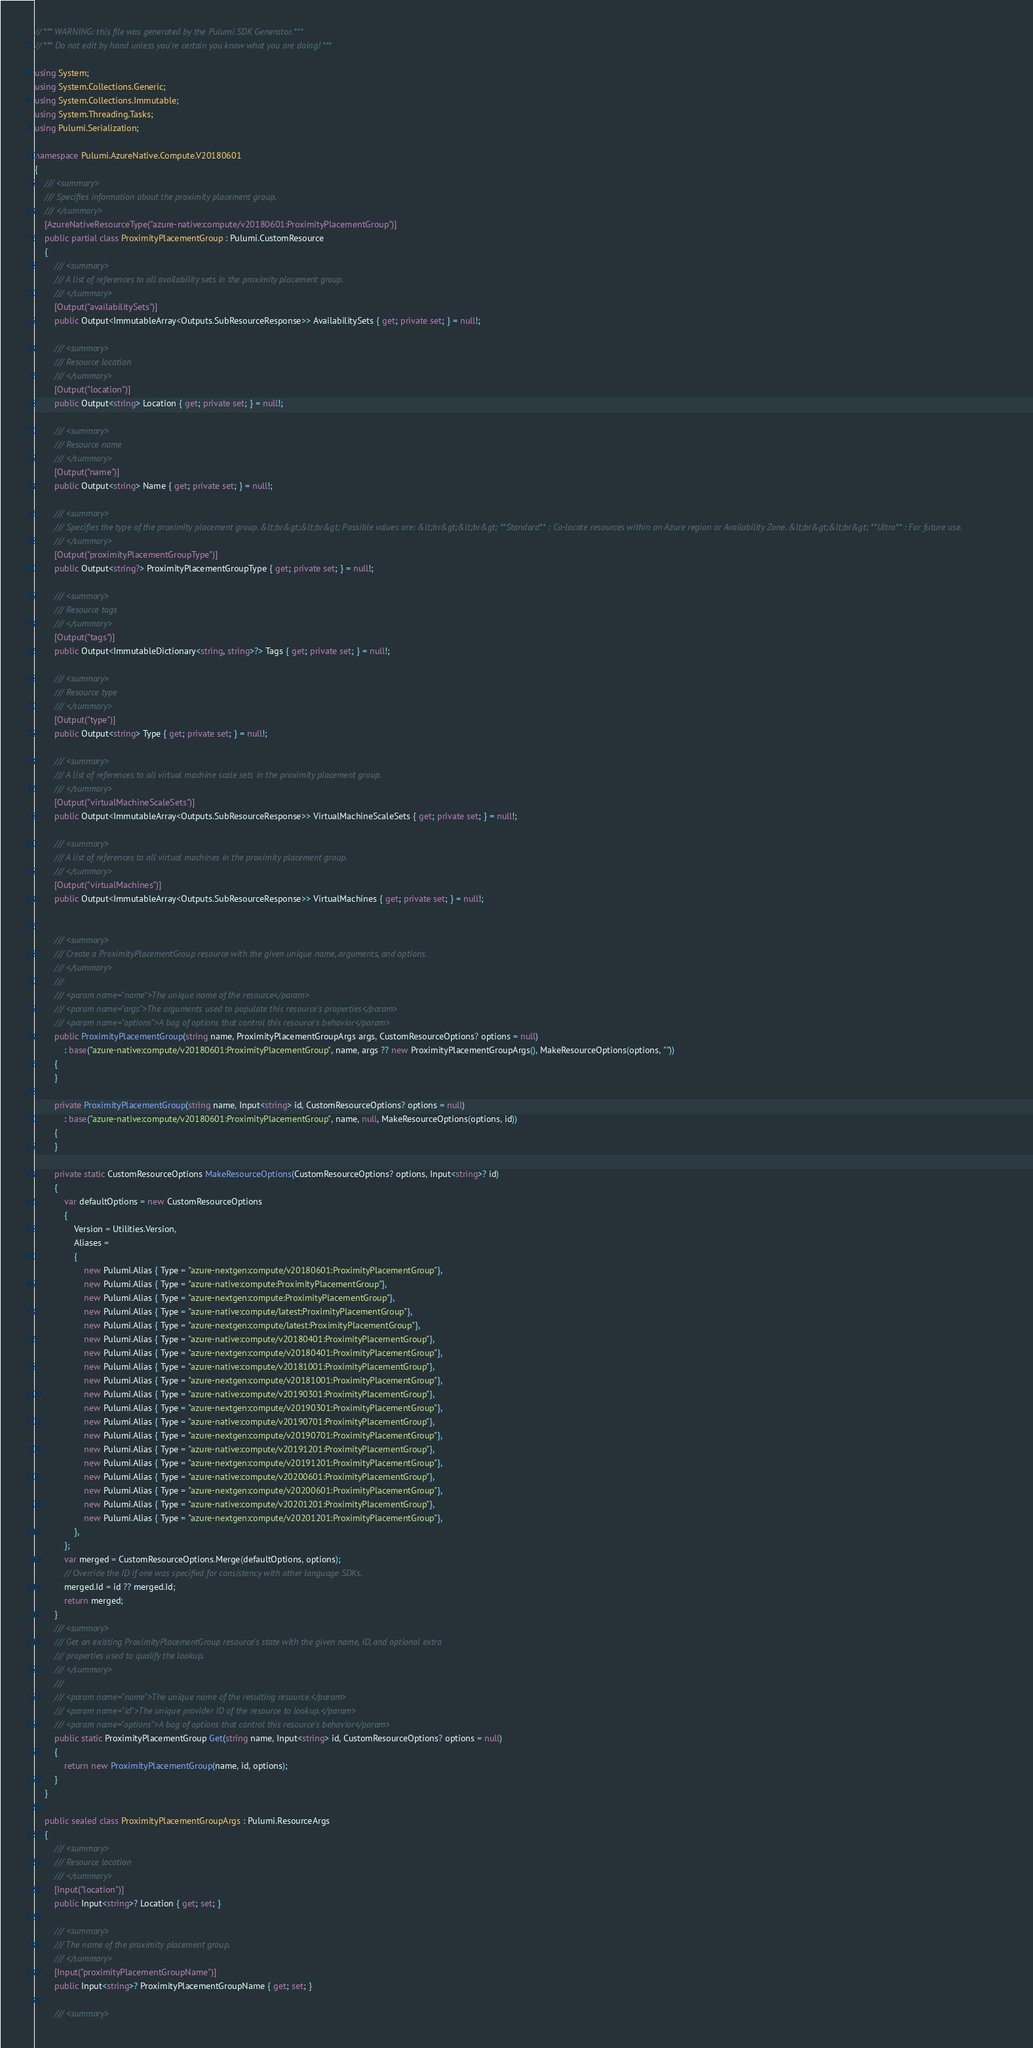Convert code to text. <code><loc_0><loc_0><loc_500><loc_500><_C#_>// *** WARNING: this file was generated by the Pulumi SDK Generator. ***
// *** Do not edit by hand unless you're certain you know what you are doing! ***

using System;
using System.Collections.Generic;
using System.Collections.Immutable;
using System.Threading.Tasks;
using Pulumi.Serialization;

namespace Pulumi.AzureNative.Compute.V20180601
{
    /// <summary>
    /// Specifies information about the proximity placement group.
    /// </summary>
    [AzureNativeResourceType("azure-native:compute/v20180601:ProximityPlacementGroup")]
    public partial class ProximityPlacementGroup : Pulumi.CustomResource
    {
        /// <summary>
        /// A list of references to all availability sets in the proximity placement group.
        /// </summary>
        [Output("availabilitySets")]
        public Output<ImmutableArray<Outputs.SubResourceResponse>> AvailabilitySets { get; private set; } = null!;

        /// <summary>
        /// Resource location
        /// </summary>
        [Output("location")]
        public Output<string> Location { get; private set; } = null!;

        /// <summary>
        /// Resource name
        /// </summary>
        [Output("name")]
        public Output<string> Name { get; private set; } = null!;

        /// <summary>
        /// Specifies the type of the proximity placement group. &lt;br&gt;&lt;br&gt; Possible values are: &lt;br&gt;&lt;br&gt; **Standard** : Co-locate resources within an Azure region or Availability Zone. &lt;br&gt;&lt;br&gt; **Ultra** : For future use.
        /// </summary>
        [Output("proximityPlacementGroupType")]
        public Output<string?> ProximityPlacementGroupType { get; private set; } = null!;

        /// <summary>
        /// Resource tags
        /// </summary>
        [Output("tags")]
        public Output<ImmutableDictionary<string, string>?> Tags { get; private set; } = null!;

        /// <summary>
        /// Resource type
        /// </summary>
        [Output("type")]
        public Output<string> Type { get; private set; } = null!;

        /// <summary>
        /// A list of references to all virtual machine scale sets in the proximity placement group.
        /// </summary>
        [Output("virtualMachineScaleSets")]
        public Output<ImmutableArray<Outputs.SubResourceResponse>> VirtualMachineScaleSets { get; private set; } = null!;

        /// <summary>
        /// A list of references to all virtual machines in the proximity placement group.
        /// </summary>
        [Output("virtualMachines")]
        public Output<ImmutableArray<Outputs.SubResourceResponse>> VirtualMachines { get; private set; } = null!;


        /// <summary>
        /// Create a ProximityPlacementGroup resource with the given unique name, arguments, and options.
        /// </summary>
        ///
        /// <param name="name">The unique name of the resource</param>
        /// <param name="args">The arguments used to populate this resource's properties</param>
        /// <param name="options">A bag of options that control this resource's behavior</param>
        public ProximityPlacementGroup(string name, ProximityPlacementGroupArgs args, CustomResourceOptions? options = null)
            : base("azure-native:compute/v20180601:ProximityPlacementGroup", name, args ?? new ProximityPlacementGroupArgs(), MakeResourceOptions(options, ""))
        {
        }

        private ProximityPlacementGroup(string name, Input<string> id, CustomResourceOptions? options = null)
            : base("azure-native:compute/v20180601:ProximityPlacementGroup", name, null, MakeResourceOptions(options, id))
        {
        }

        private static CustomResourceOptions MakeResourceOptions(CustomResourceOptions? options, Input<string>? id)
        {
            var defaultOptions = new CustomResourceOptions
            {
                Version = Utilities.Version,
                Aliases =
                {
                    new Pulumi.Alias { Type = "azure-nextgen:compute/v20180601:ProximityPlacementGroup"},
                    new Pulumi.Alias { Type = "azure-native:compute:ProximityPlacementGroup"},
                    new Pulumi.Alias { Type = "azure-nextgen:compute:ProximityPlacementGroup"},
                    new Pulumi.Alias { Type = "azure-native:compute/latest:ProximityPlacementGroup"},
                    new Pulumi.Alias { Type = "azure-nextgen:compute/latest:ProximityPlacementGroup"},
                    new Pulumi.Alias { Type = "azure-native:compute/v20180401:ProximityPlacementGroup"},
                    new Pulumi.Alias { Type = "azure-nextgen:compute/v20180401:ProximityPlacementGroup"},
                    new Pulumi.Alias { Type = "azure-native:compute/v20181001:ProximityPlacementGroup"},
                    new Pulumi.Alias { Type = "azure-nextgen:compute/v20181001:ProximityPlacementGroup"},
                    new Pulumi.Alias { Type = "azure-native:compute/v20190301:ProximityPlacementGroup"},
                    new Pulumi.Alias { Type = "azure-nextgen:compute/v20190301:ProximityPlacementGroup"},
                    new Pulumi.Alias { Type = "azure-native:compute/v20190701:ProximityPlacementGroup"},
                    new Pulumi.Alias { Type = "azure-nextgen:compute/v20190701:ProximityPlacementGroup"},
                    new Pulumi.Alias { Type = "azure-native:compute/v20191201:ProximityPlacementGroup"},
                    new Pulumi.Alias { Type = "azure-nextgen:compute/v20191201:ProximityPlacementGroup"},
                    new Pulumi.Alias { Type = "azure-native:compute/v20200601:ProximityPlacementGroup"},
                    new Pulumi.Alias { Type = "azure-nextgen:compute/v20200601:ProximityPlacementGroup"},
                    new Pulumi.Alias { Type = "azure-native:compute/v20201201:ProximityPlacementGroup"},
                    new Pulumi.Alias { Type = "azure-nextgen:compute/v20201201:ProximityPlacementGroup"},
                },
            };
            var merged = CustomResourceOptions.Merge(defaultOptions, options);
            // Override the ID if one was specified for consistency with other language SDKs.
            merged.Id = id ?? merged.Id;
            return merged;
        }
        /// <summary>
        /// Get an existing ProximityPlacementGroup resource's state with the given name, ID, and optional extra
        /// properties used to qualify the lookup.
        /// </summary>
        ///
        /// <param name="name">The unique name of the resulting resource.</param>
        /// <param name="id">The unique provider ID of the resource to lookup.</param>
        /// <param name="options">A bag of options that control this resource's behavior</param>
        public static ProximityPlacementGroup Get(string name, Input<string> id, CustomResourceOptions? options = null)
        {
            return new ProximityPlacementGroup(name, id, options);
        }
    }

    public sealed class ProximityPlacementGroupArgs : Pulumi.ResourceArgs
    {
        /// <summary>
        /// Resource location
        /// </summary>
        [Input("location")]
        public Input<string>? Location { get; set; }

        /// <summary>
        /// The name of the proximity placement group.
        /// </summary>
        [Input("proximityPlacementGroupName")]
        public Input<string>? ProximityPlacementGroupName { get; set; }

        /// <summary></code> 